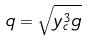Convert formula to latex. <formula><loc_0><loc_0><loc_500><loc_500>q = \sqrt { y _ { c } ^ { 3 } g }</formula> 